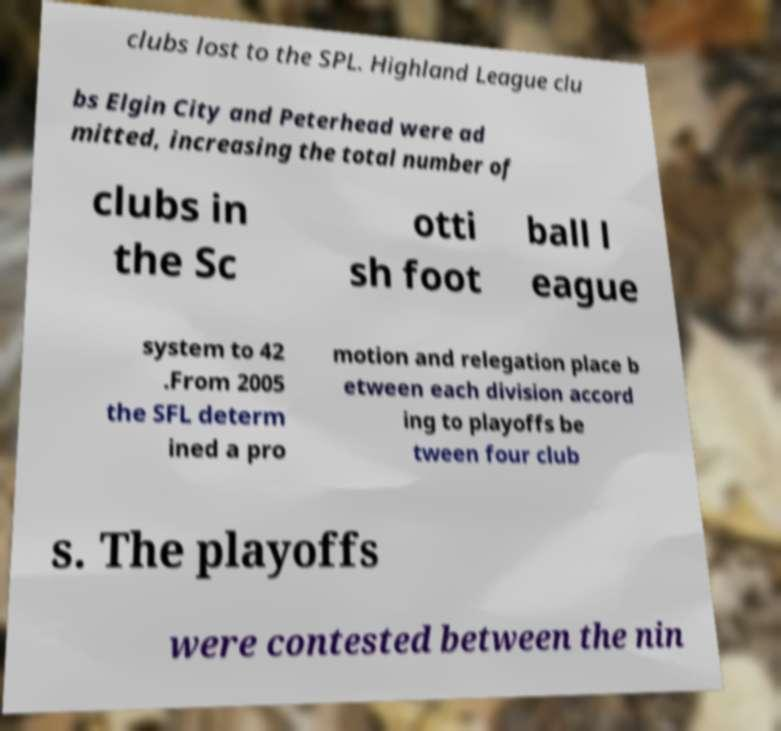I need the written content from this picture converted into text. Can you do that? clubs lost to the SPL. Highland League clu bs Elgin City and Peterhead were ad mitted, increasing the total number of clubs in the Sc otti sh foot ball l eague system to 42 .From 2005 the SFL determ ined a pro motion and relegation place b etween each division accord ing to playoffs be tween four club s. The playoffs were contested between the nin 